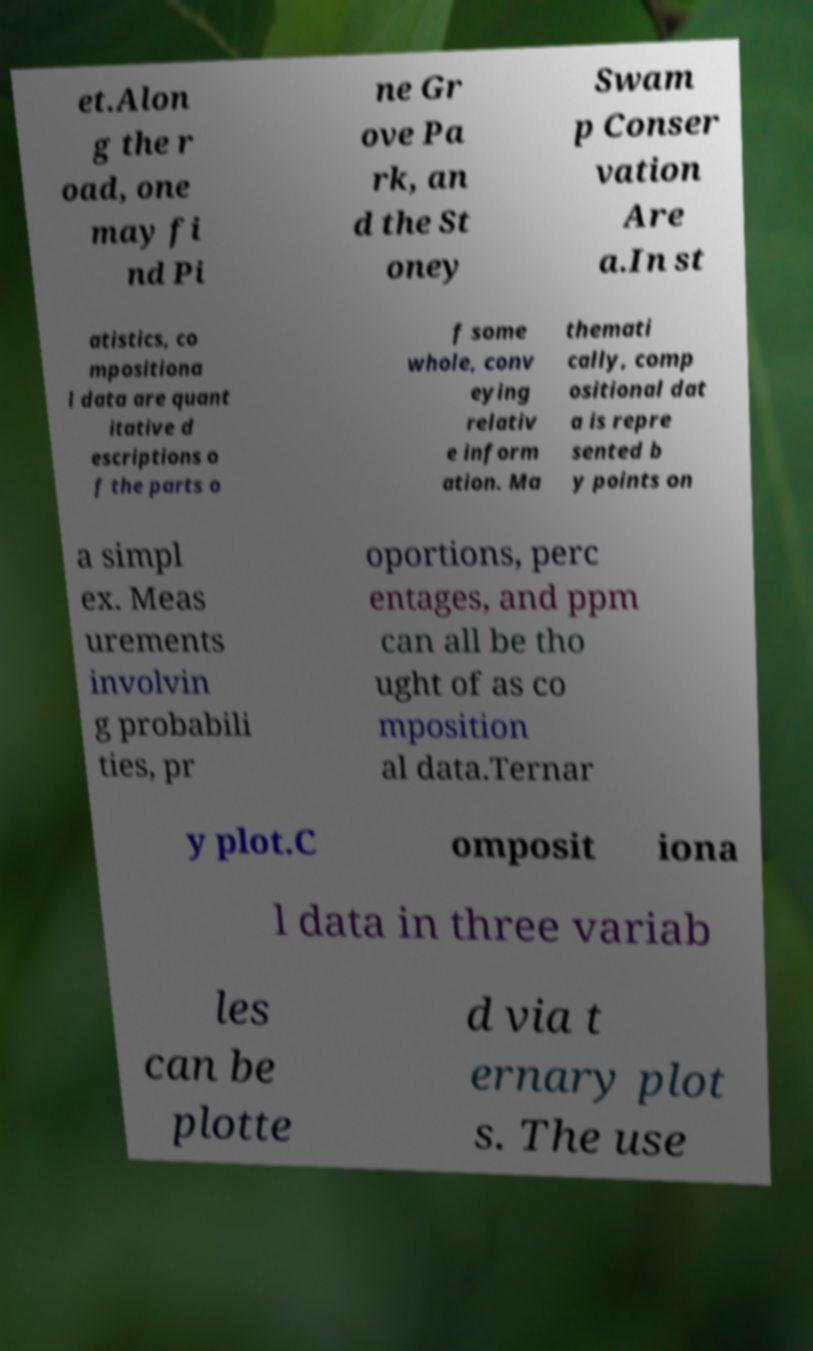Can you read and provide the text displayed in the image?This photo seems to have some interesting text. Can you extract and type it out for me? et.Alon g the r oad, one may fi nd Pi ne Gr ove Pa rk, an d the St oney Swam p Conser vation Are a.In st atistics, co mpositiona l data are quant itative d escriptions o f the parts o f some whole, conv eying relativ e inform ation. Ma themati cally, comp ositional dat a is repre sented b y points on a simpl ex. Meas urements involvin g probabili ties, pr oportions, perc entages, and ppm can all be tho ught of as co mposition al data.Ternar y plot.C omposit iona l data in three variab les can be plotte d via t ernary plot s. The use 